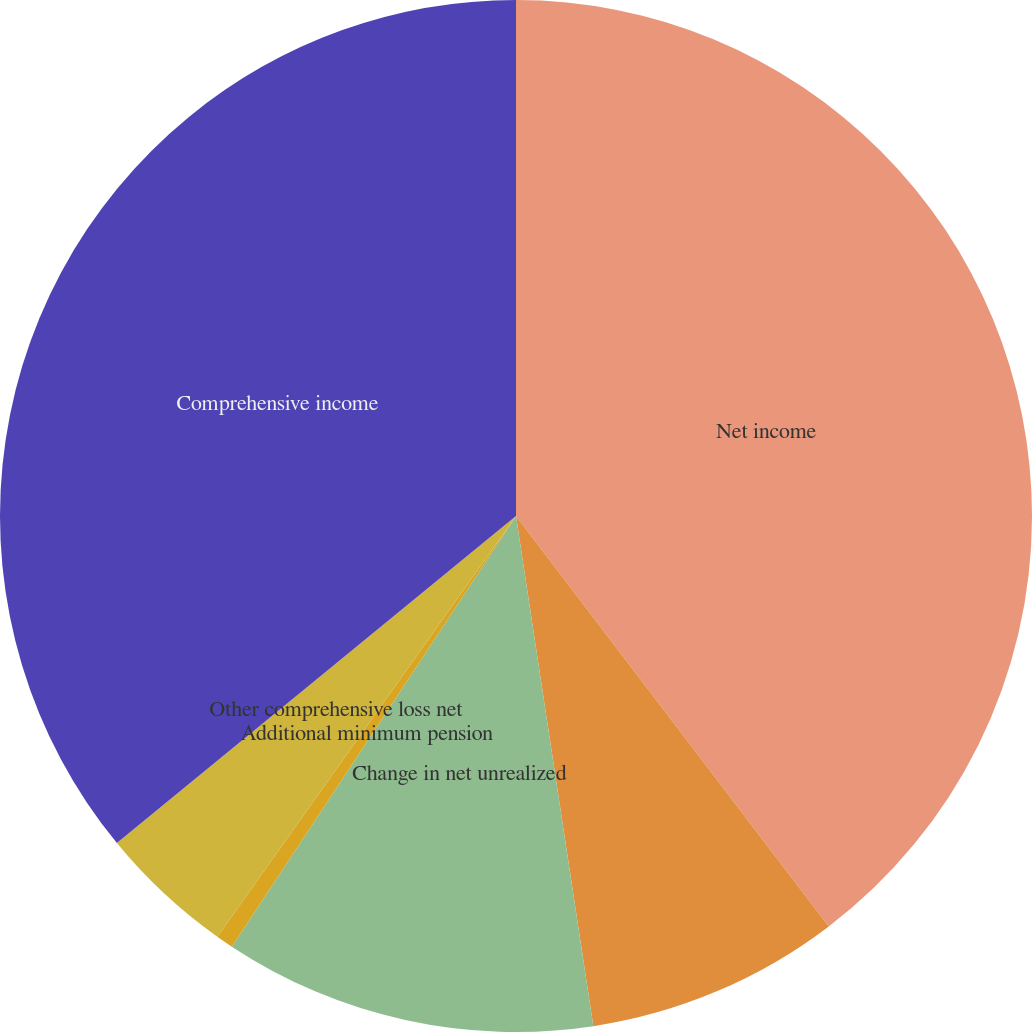Convert chart to OTSL. <chart><loc_0><loc_0><loc_500><loc_500><pie_chart><fcel>Net income<fcel>Change in foreign currency<fcel>Change in net unrealized<fcel>Additional minimum pension<fcel>Other comprehensive loss net<fcel>Comprehensive income<nl><fcel>39.64%<fcel>7.97%<fcel>11.68%<fcel>0.54%<fcel>4.25%<fcel>35.93%<nl></chart> 